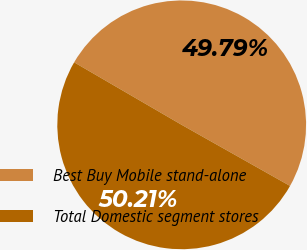Convert chart to OTSL. <chart><loc_0><loc_0><loc_500><loc_500><pie_chart><fcel>Best Buy Mobile stand-alone<fcel>Total Domestic segment stores<nl><fcel>49.79%<fcel>50.21%<nl></chart> 